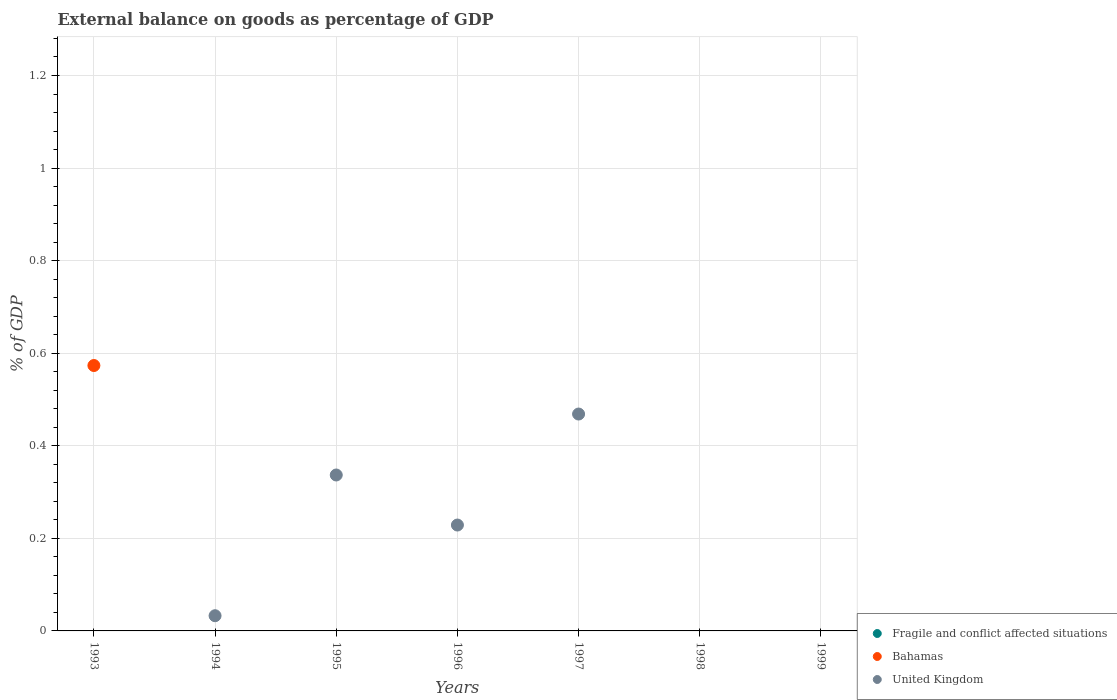What is the external balance on goods as percentage of GDP in Fragile and conflict affected situations in 1997?
Make the answer very short. 0. Across all years, what is the maximum external balance on goods as percentage of GDP in United Kingdom?
Ensure brevity in your answer.  0.47. What is the difference between the external balance on goods as percentage of GDP in United Kingdom in 1996 and that in 1997?
Provide a short and direct response. -0.24. What is the average external balance on goods as percentage of GDP in United Kingdom per year?
Provide a succinct answer. 0.15. Is the external balance on goods as percentage of GDP in United Kingdom in 1994 less than that in 1995?
Keep it short and to the point. Yes. What is the difference between the highest and the lowest external balance on goods as percentage of GDP in Bahamas?
Your response must be concise. 0.57. In how many years, is the external balance on goods as percentage of GDP in Bahamas greater than the average external balance on goods as percentage of GDP in Bahamas taken over all years?
Your response must be concise. 1. Is it the case that in every year, the sum of the external balance on goods as percentage of GDP in Fragile and conflict affected situations and external balance on goods as percentage of GDP in Bahamas  is greater than the external balance on goods as percentage of GDP in United Kingdom?
Make the answer very short. No. Does the external balance on goods as percentage of GDP in United Kingdom monotonically increase over the years?
Offer a terse response. No. How many years are there in the graph?
Give a very brief answer. 7. Are the values on the major ticks of Y-axis written in scientific E-notation?
Your response must be concise. No. Does the graph contain any zero values?
Give a very brief answer. Yes. Where does the legend appear in the graph?
Your response must be concise. Bottom right. How many legend labels are there?
Make the answer very short. 3. How are the legend labels stacked?
Keep it short and to the point. Vertical. What is the title of the graph?
Offer a very short reply. External balance on goods as percentage of GDP. What is the label or title of the Y-axis?
Offer a terse response. % of GDP. What is the % of GDP of Bahamas in 1993?
Provide a succinct answer. 0.57. What is the % of GDP of Fragile and conflict affected situations in 1994?
Offer a very short reply. 0. What is the % of GDP in Bahamas in 1994?
Keep it short and to the point. 0. What is the % of GDP in United Kingdom in 1994?
Offer a terse response. 0.03. What is the % of GDP of Bahamas in 1995?
Make the answer very short. 0. What is the % of GDP of United Kingdom in 1995?
Your answer should be compact. 0.34. What is the % of GDP in United Kingdom in 1996?
Your answer should be compact. 0.23. What is the % of GDP in United Kingdom in 1997?
Provide a succinct answer. 0.47. What is the % of GDP of Fragile and conflict affected situations in 1998?
Offer a terse response. 0. What is the % of GDP of United Kingdom in 1998?
Offer a terse response. 0. What is the % of GDP in United Kingdom in 1999?
Keep it short and to the point. 0. Across all years, what is the maximum % of GDP in Bahamas?
Your answer should be very brief. 0.57. Across all years, what is the maximum % of GDP of United Kingdom?
Your response must be concise. 0.47. Across all years, what is the minimum % of GDP in Bahamas?
Keep it short and to the point. 0. What is the total % of GDP of Fragile and conflict affected situations in the graph?
Ensure brevity in your answer.  0. What is the total % of GDP of Bahamas in the graph?
Offer a terse response. 0.57. What is the total % of GDP of United Kingdom in the graph?
Offer a terse response. 1.07. What is the difference between the % of GDP in United Kingdom in 1994 and that in 1995?
Keep it short and to the point. -0.3. What is the difference between the % of GDP of United Kingdom in 1994 and that in 1996?
Give a very brief answer. -0.2. What is the difference between the % of GDP of United Kingdom in 1994 and that in 1997?
Make the answer very short. -0.44. What is the difference between the % of GDP of United Kingdom in 1995 and that in 1996?
Keep it short and to the point. 0.11. What is the difference between the % of GDP in United Kingdom in 1995 and that in 1997?
Offer a terse response. -0.13. What is the difference between the % of GDP of United Kingdom in 1996 and that in 1997?
Provide a short and direct response. -0.24. What is the difference between the % of GDP of Bahamas in 1993 and the % of GDP of United Kingdom in 1994?
Make the answer very short. 0.54. What is the difference between the % of GDP of Bahamas in 1993 and the % of GDP of United Kingdom in 1995?
Give a very brief answer. 0.24. What is the difference between the % of GDP in Bahamas in 1993 and the % of GDP in United Kingdom in 1996?
Your response must be concise. 0.34. What is the difference between the % of GDP in Bahamas in 1993 and the % of GDP in United Kingdom in 1997?
Your answer should be compact. 0.1. What is the average % of GDP of Fragile and conflict affected situations per year?
Offer a very short reply. 0. What is the average % of GDP of Bahamas per year?
Ensure brevity in your answer.  0.08. What is the average % of GDP of United Kingdom per year?
Offer a very short reply. 0.15. What is the ratio of the % of GDP of United Kingdom in 1994 to that in 1995?
Offer a very short reply. 0.1. What is the ratio of the % of GDP in United Kingdom in 1994 to that in 1996?
Offer a very short reply. 0.14. What is the ratio of the % of GDP in United Kingdom in 1994 to that in 1997?
Ensure brevity in your answer.  0.07. What is the ratio of the % of GDP in United Kingdom in 1995 to that in 1996?
Provide a succinct answer. 1.47. What is the ratio of the % of GDP of United Kingdom in 1995 to that in 1997?
Ensure brevity in your answer.  0.72. What is the ratio of the % of GDP of United Kingdom in 1996 to that in 1997?
Provide a short and direct response. 0.49. What is the difference between the highest and the second highest % of GDP of United Kingdom?
Make the answer very short. 0.13. What is the difference between the highest and the lowest % of GDP of Bahamas?
Your answer should be compact. 0.57. What is the difference between the highest and the lowest % of GDP in United Kingdom?
Make the answer very short. 0.47. 